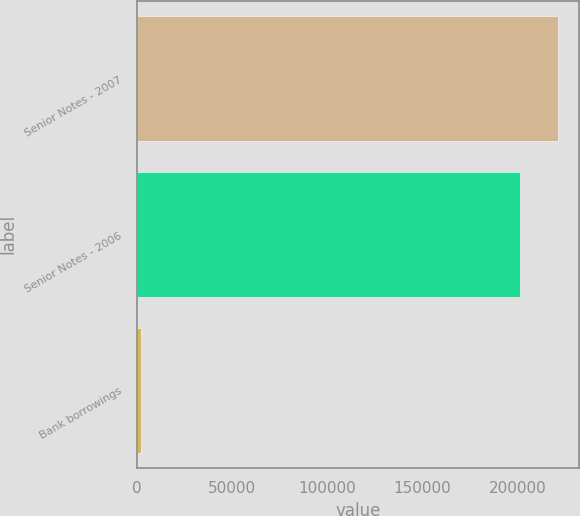<chart> <loc_0><loc_0><loc_500><loc_500><bar_chart><fcel>Senior Notes - 2007<fcel>Senior Notes - 2006<fcel>Bank borrowings<nl><fcel>221288<fcel>201316<fcel>2012<nl></chart> 